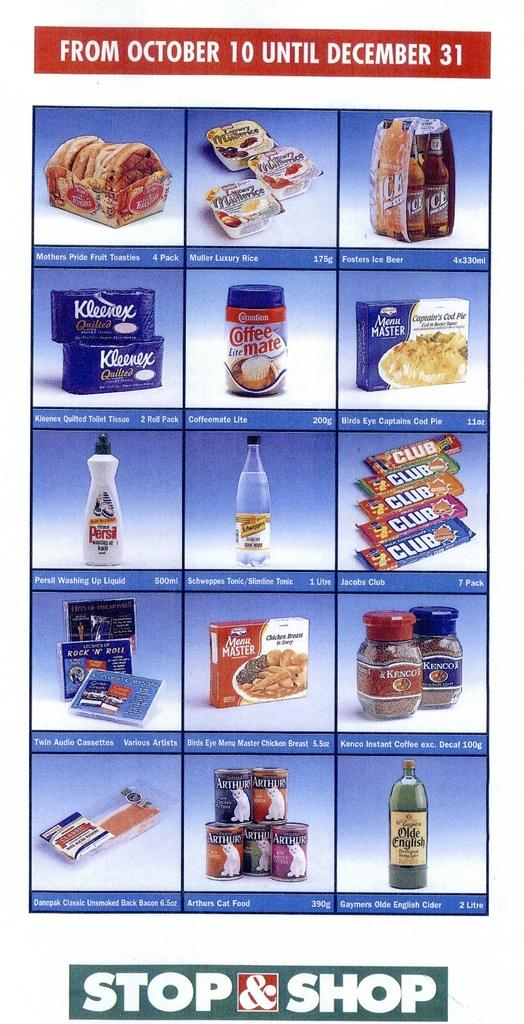What is present on the poster in the image? There is a poster in the image that contains both text and images. Can you describe the content of the poster? The poster contains text and images, but the specific content cannot be determined from the provided facts. What is the tendency of the plough in the image? There is no plough present in the image, so it is not possible to determine its tendency. 